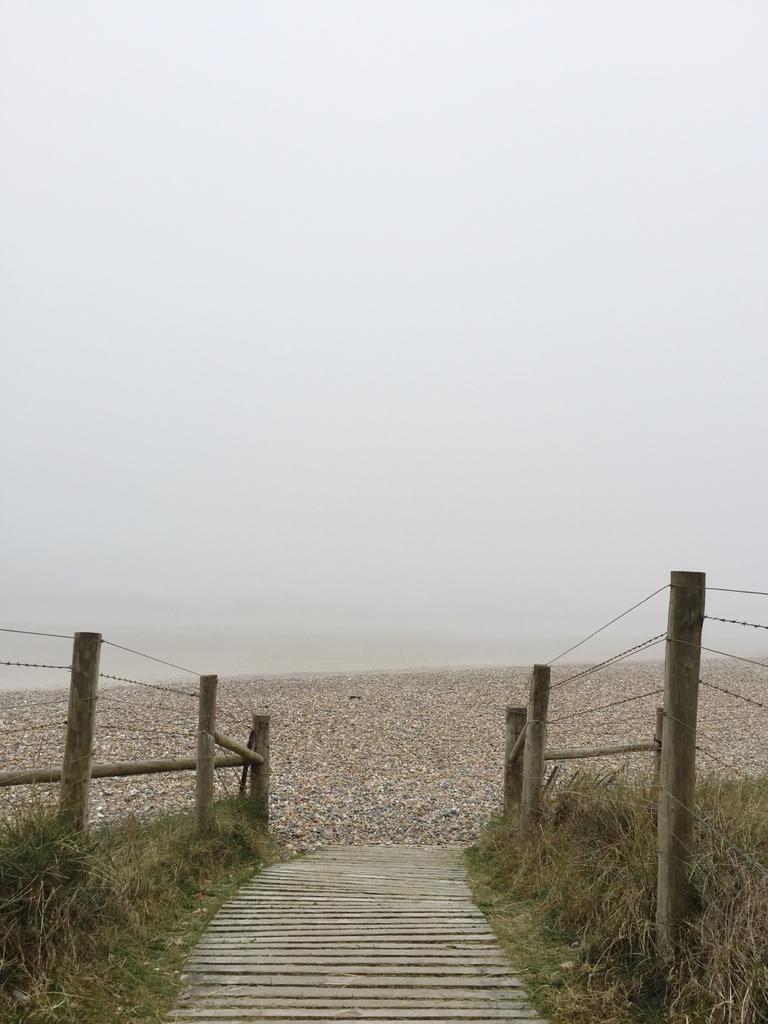Describe this image in one or two sentences. In the background we can see the sky and its blur. On either side of the pathway we can see the grass, fence and the poles. 